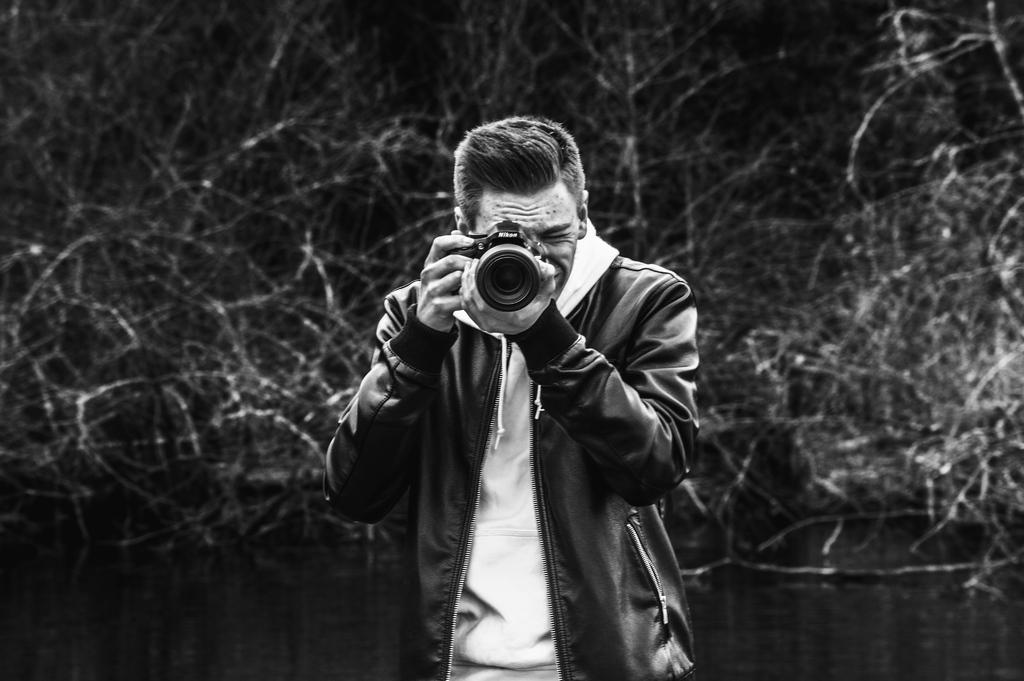What is the person in the image doing? The person is holding a camera and capturing something with it. What else can be seen in the image besides the person? There are plants visible in the image. What type of steel is being used to support the growth of the twig in the image? There is no steel or twig present in the image; it features a person holding a camera and plants in the background. 